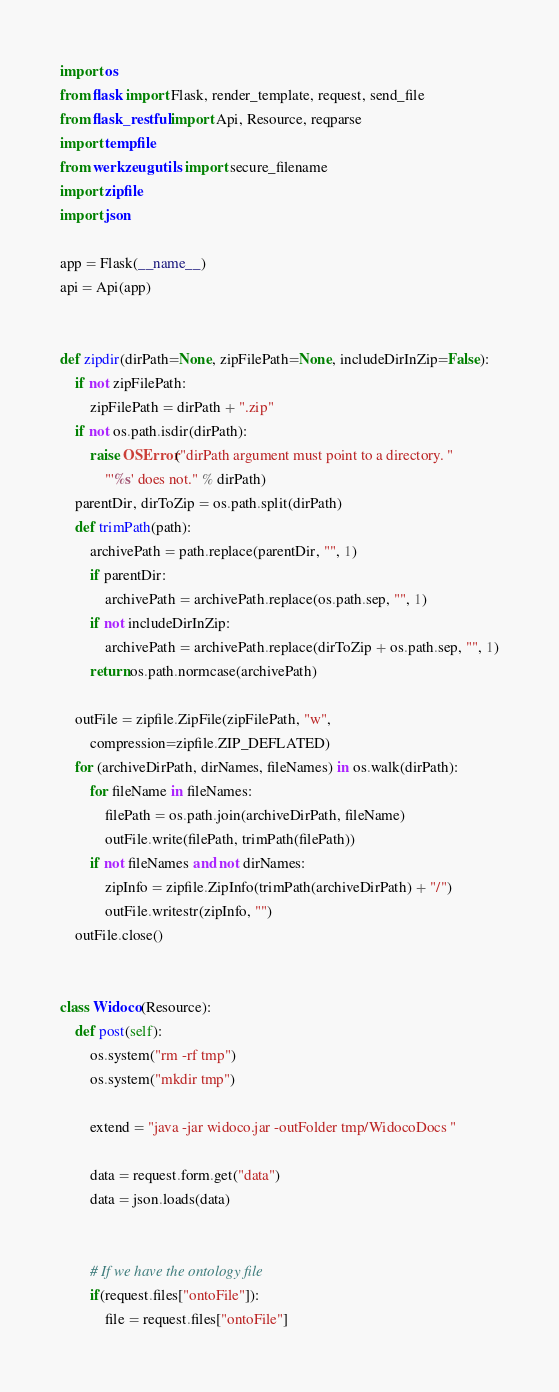<code> <loc_0><loc_0><loc_500><loc_500><_Python_>import os
from flask import Flask, render_template, request, send_file
from flask_restful import Api, Resource, reqparse
import tempfile
from werkzeug.utils import secure_filename
import zipfile
import json

app = Flask(__name__)
api = Api(app)


def zipdir(dirPath=None, zipFilePath=None, includeDirInZip=False):
    if not zipFilePath:
        zipFilePath = dirPath + ".zip"
    if not os.path.isdir(dirPath):
        raise OSError("dirPath argument must point to a directory. "
            "'%s' does not." % dirPath)
    parentDir, dirToZip = os.path.split(dirPath)
    def trimPath(path):
        archivePath = path.replace(parentDir, "", 1)
        if parentDir:
            archivePath = archivePath.replace(os.path.sep, "", 1)
        if not includeDirInZip:
            archivePath = archivePath.replace(dirToZip + os.path.sep, "", 1)
        return os.path.normcase(archivePath)

    outFile = zipfile.ZipFile(zipFilePath, "w",
        compression=zipfile.ZIP_DEFLATED)
    for (archiveDirPath, dirNames, fileNames) in os.walk(dirPath):
        for fileName in fileNames:
            filePath = os.path.join(archiveDirPath, fileName)
            outFile.write(filePath, trimPath(filePath))
        if not fileNames and not dirNames:
            zipInfo = zipfile.ZipInfo(trimPath(archiveDirPath) + "/")
            outFile.writestr(zipInfo, "")
    outFile.close()


class Widoco(Resource):
    def post(self):
        os.system("rm -rf tmp")
        os.system("mkdir tmp")

        extend = "java -jar widoco.jar -outFolder tmp/WidocoDocs "

        data = request.form.get("data")
        data = json.loads(data)


        # If we have the ontology file
        if(request.files["ontoFile"]):
            file = request.files["ontoFile"]</code> 